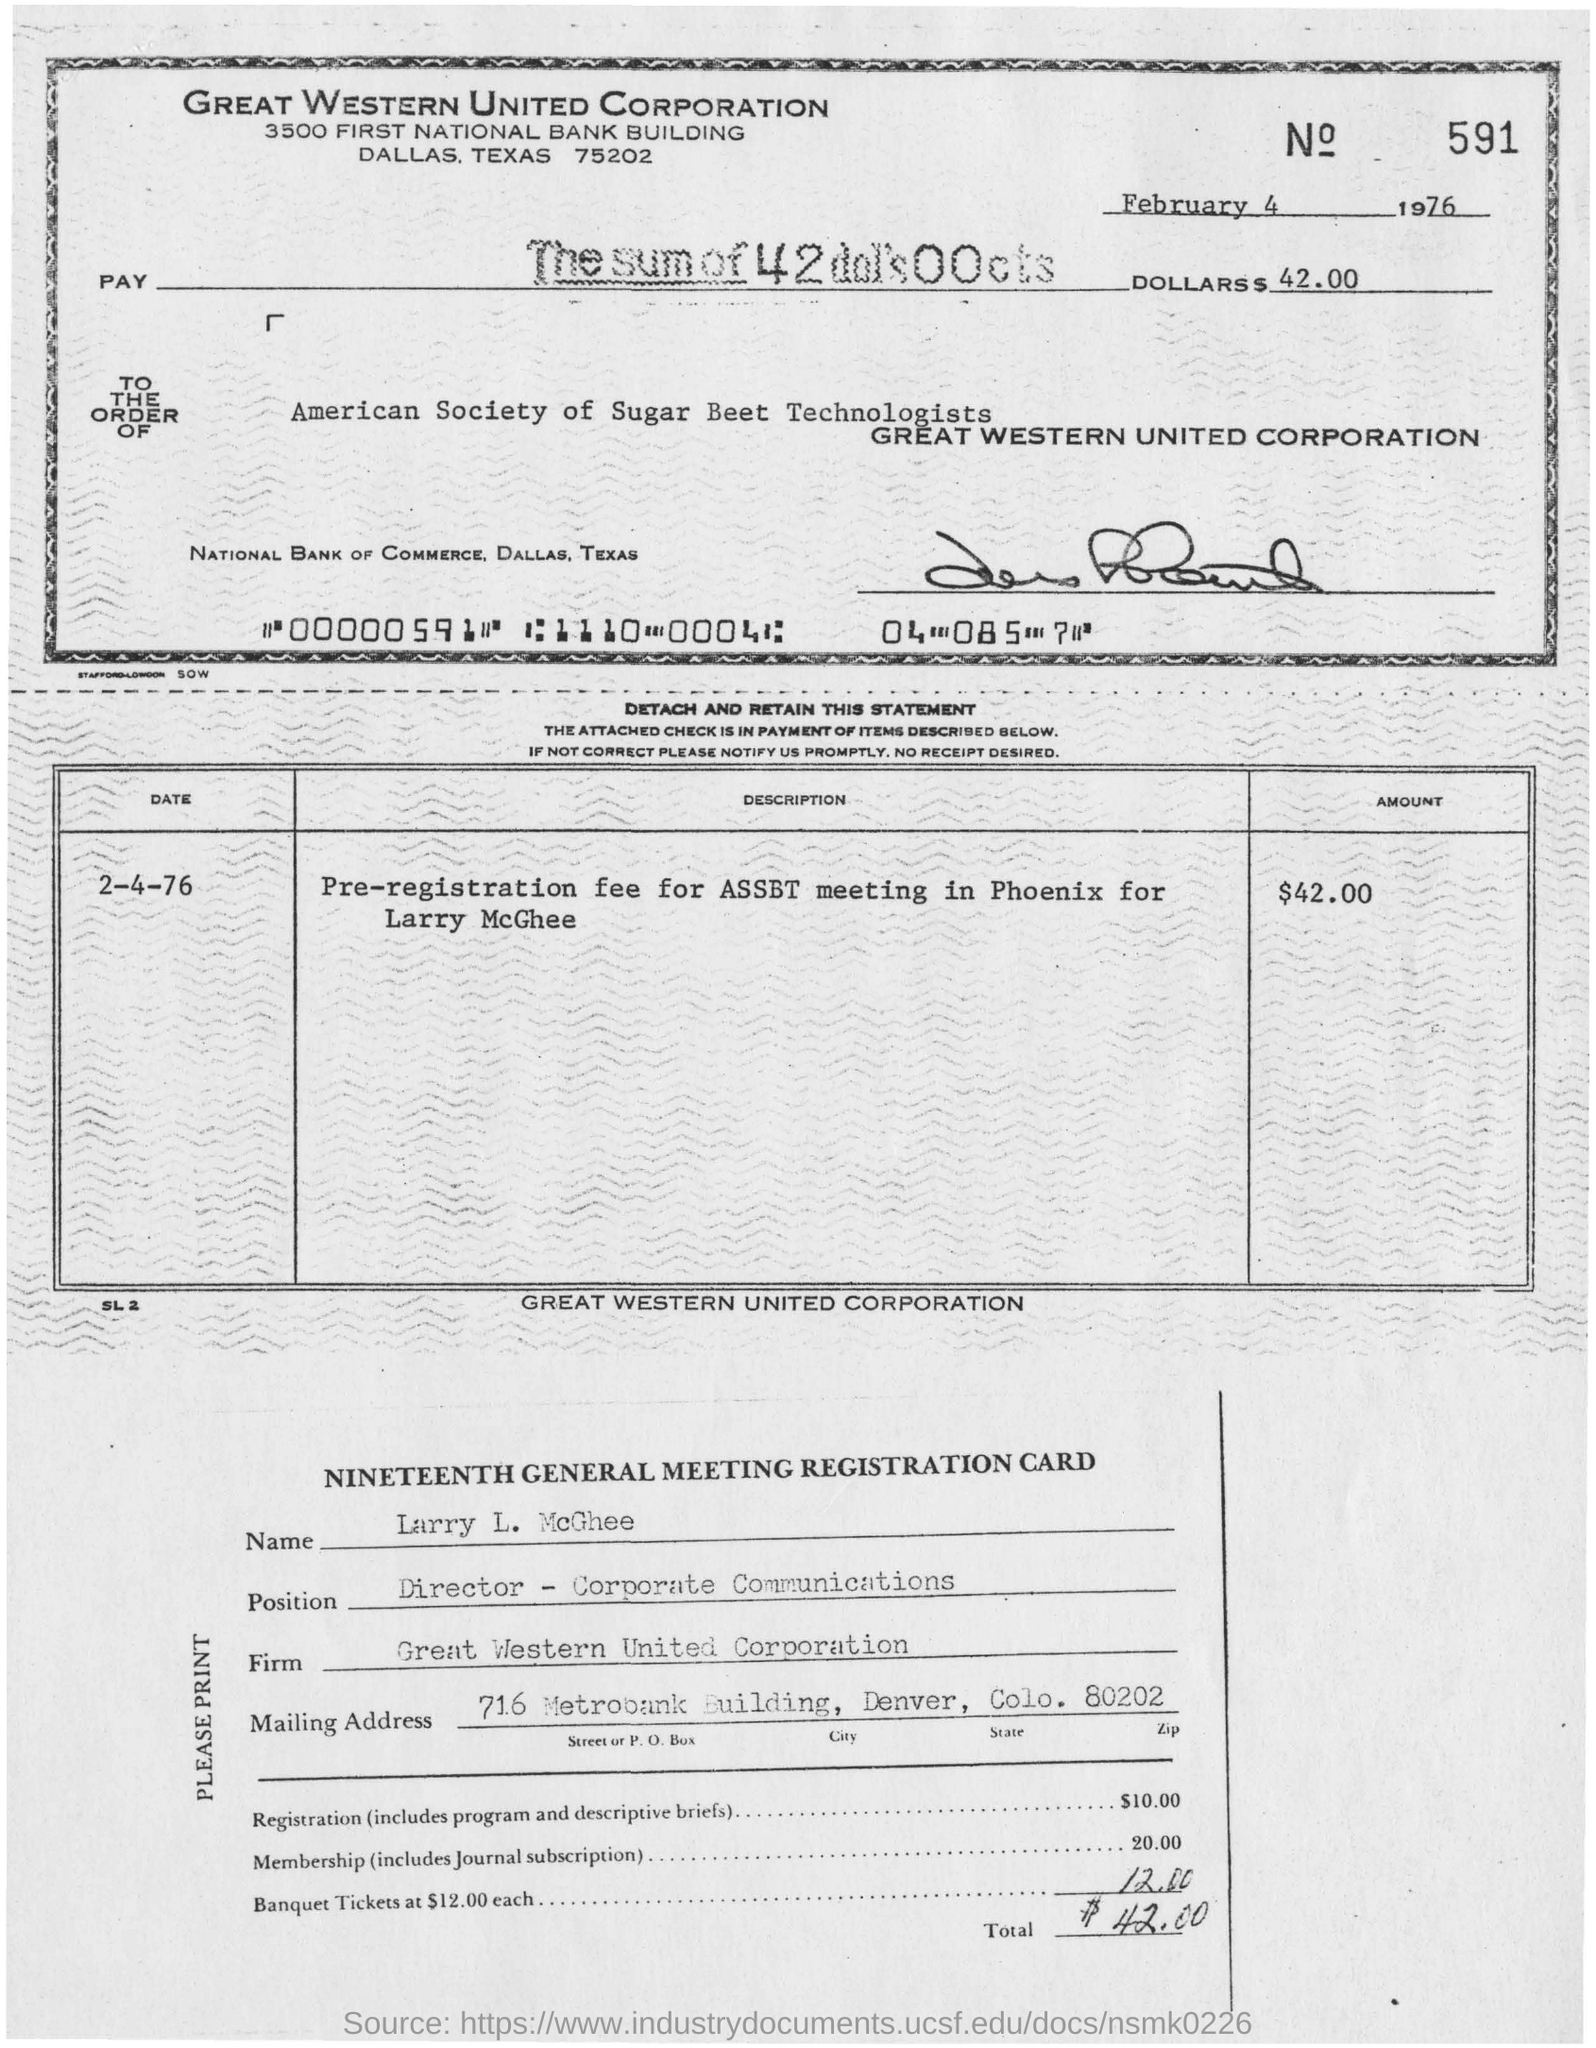Highlight a few significant elements in this photo. The pre-registration fee for the Association of State Banking Supervisors (ASBT) meeting in Phoenix, Arizona has been scheduled for Larry McGhee. The name listed in the nineteenth general meeting registration card is Larry L. McGhee. Larry L. McGhee holds the position of Director of Corporate Communications. The check is being sent to the American Society of Sugar Beet Technologists. The corporation named "Great Western United Corporation" is the subject of this declaration. 